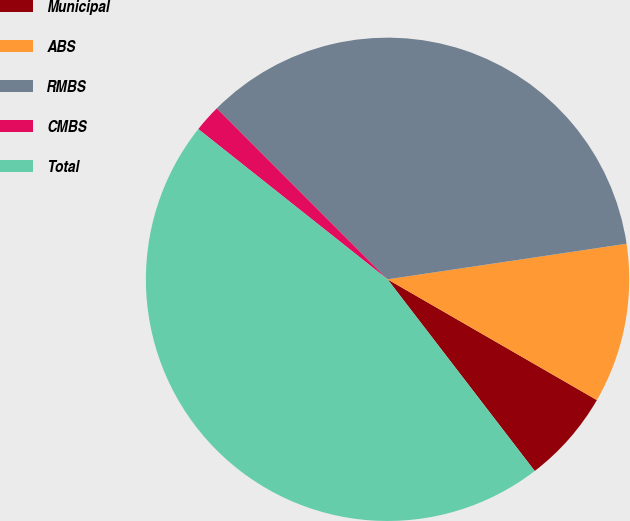Convert chart to OTSL. <chart><loc_0><loc_0><loc_500><loc_500><pie_chart><fcel>Municipal<fcel>ABS<fcel>RMBS<fcel>CMBS<fcel>Total<nl><fcel>6.25%<fcel>10.68%<fcel>35.14%<fcel>1.83%<fcel>46.1%<nl></chart> 